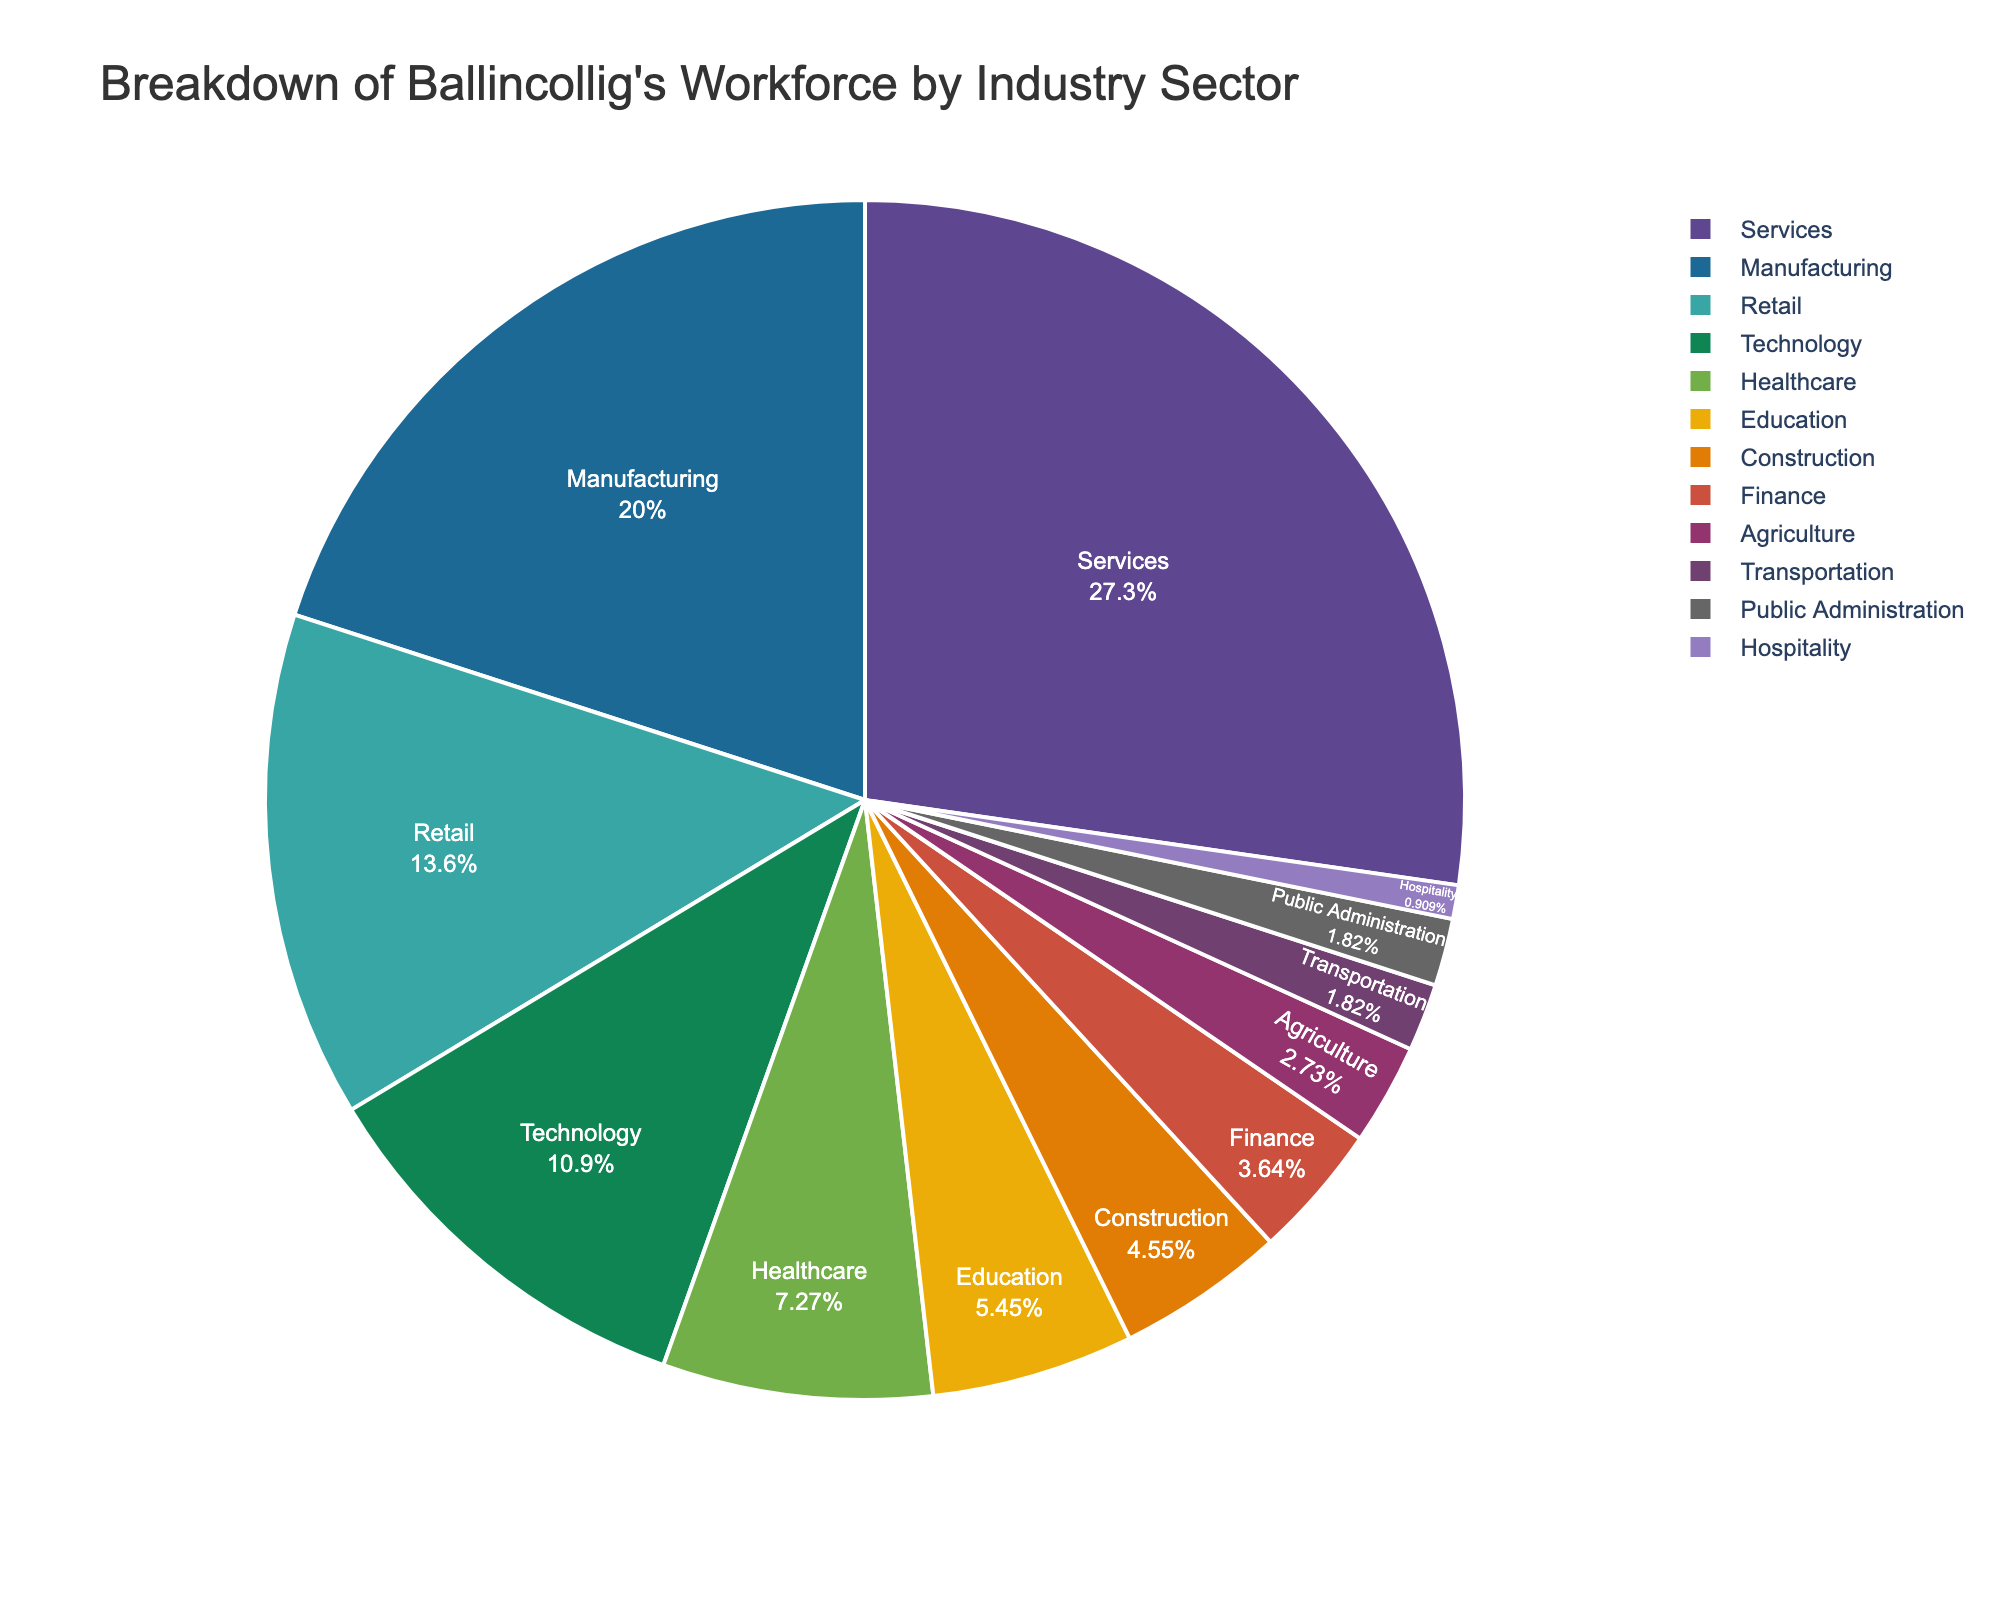What percentage of Ballincollig's workforce is employed in the services sector? Look for the slice labeled "Services" in the pie chart and note its percentage.
Answer: 30% What is the total percentage of the workforce employed in Manufacturing and Technology sectors combined? Add the percentages of Manufacturing (22%) and Technology (12%) sectors. 22 + 12 = 34.
Answer: 34% Which sector employs more people, Healthcare or Education? Compare the percentages of Healthcare (8%) and Education (6%) sectors.
Answer: Healthcare Is the percentage of people working in Agriculture and Transportation together smaller than those in Retail? Add the percentages for Agriculture (3%) and Transportation (2%), then compare the sum (5%) to Retail (15%). 5% < 15%.
Answer: Yes Which sector has the smallest representation in Ballincollig's workforce? Identify the sector with the smallest slice in the pie chart, which is Hospitality (1%).
Answer: Hospitality How much greater is the percentage of the workforce in the Services sector compared to the Finance sector? Subtract the percentage of Finance (4%) from that of Services (30%). 30 - 4 = 26.
Answer: 26% What is the combined percentage of the workforce in the sectors of Public Administration, Hospitality, and Agriculture? Add the percentages for Public Administration (2%), Hospitality (1%), and Agriculture (3%). 2 + 1 + 3 = 6.
Answer: 6% Is the workforce percentage in Construction greater than the combined percentage of Public Administration and Hospitality? Compare Construction (5%) with the sum of Public Administration (2%) and Hospitality (1%), which is 3%. 5% > 3%.
Answer: Yes Which sector employs more people, Construction or Education? Compare the percentages of Construction (5%) and Education (6%) sectors.
Answer: Education If you were to merge the percentage of the workforce in the Technology sector with the percentage in the Healthcare sector, what would the new combined percentage be? Sum the percentages of Technology (12%) and Healthcare (8%). 12 + 8 = 20.
Answer: 20% 